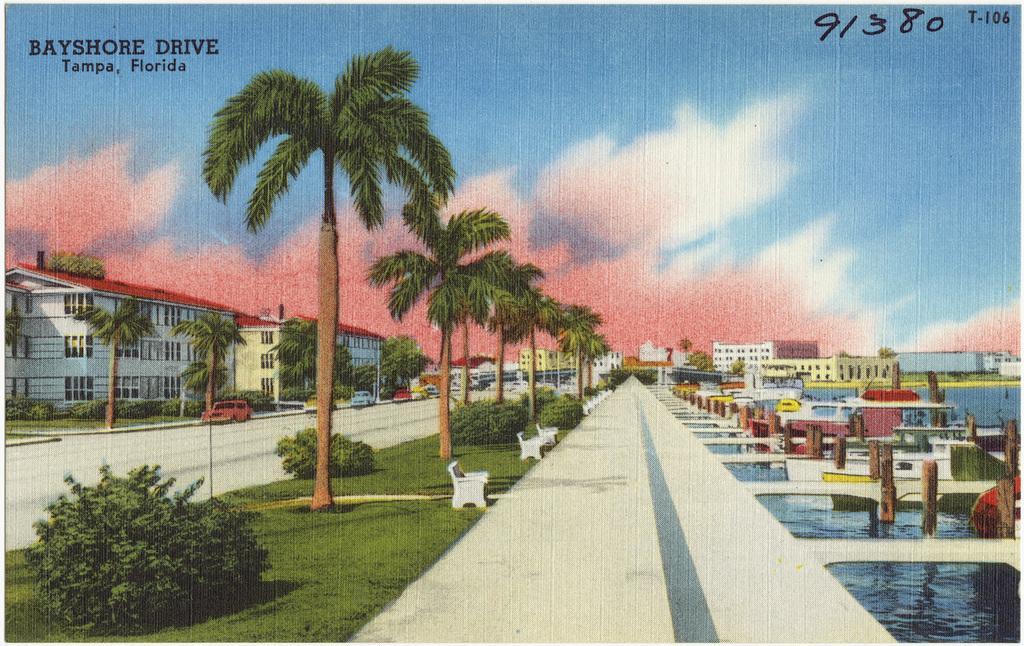Describe this image in one or two sentences. In this image we can see a painting. On the painting there are trees, benches and plants. Also there are buildings with windows. And there are vehicles on the road. On the right side there is water. And there are boats on the water. Also there are poles. In the background there is sky with clouds. Also there is text and numbers on the image. 